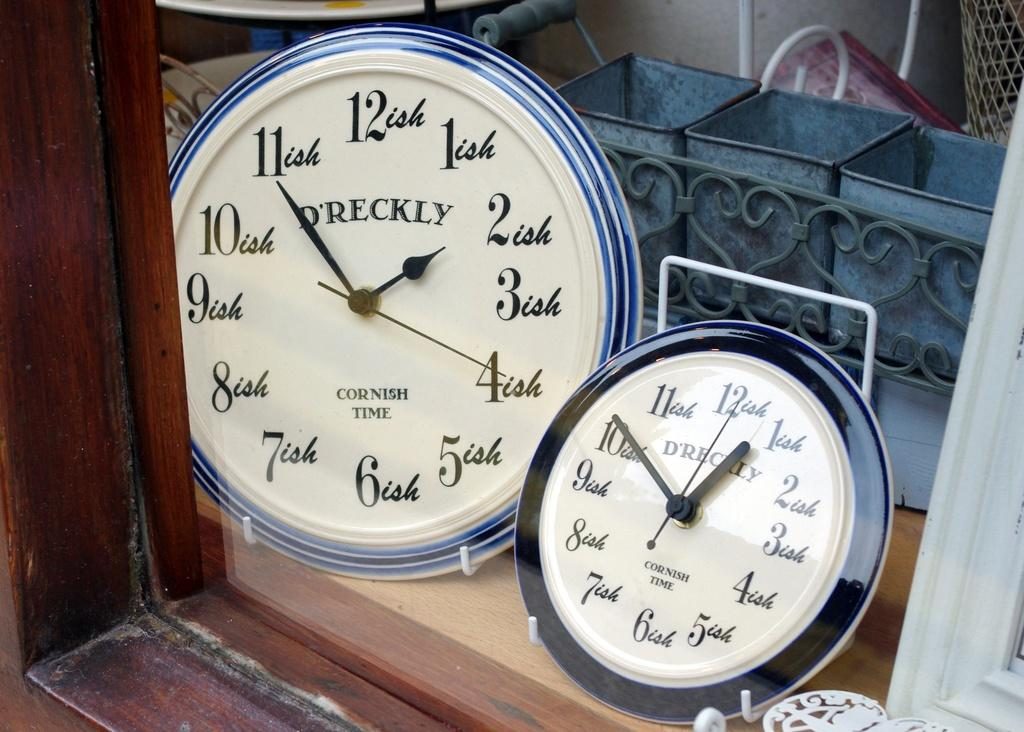<image>
Share a concise interpretation of the image provided. the number 12 that is on a clock 